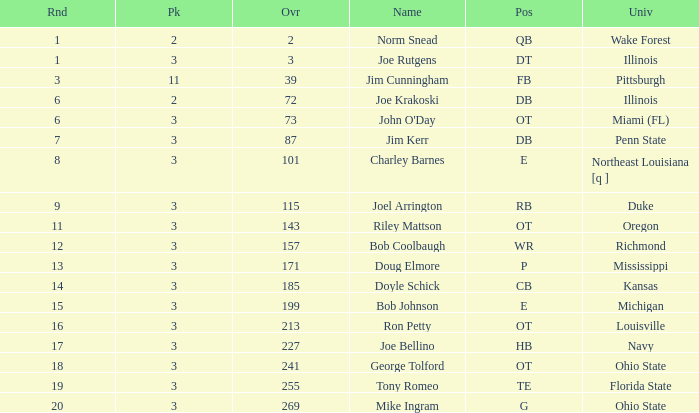How many overalls have charley barnes as the name, with a pick less than 3? None. 